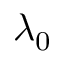Convert formula to latex. <formula><loc_0><loc_0><loc_500><loc_500>\lambda _ { 0 }</formula> 